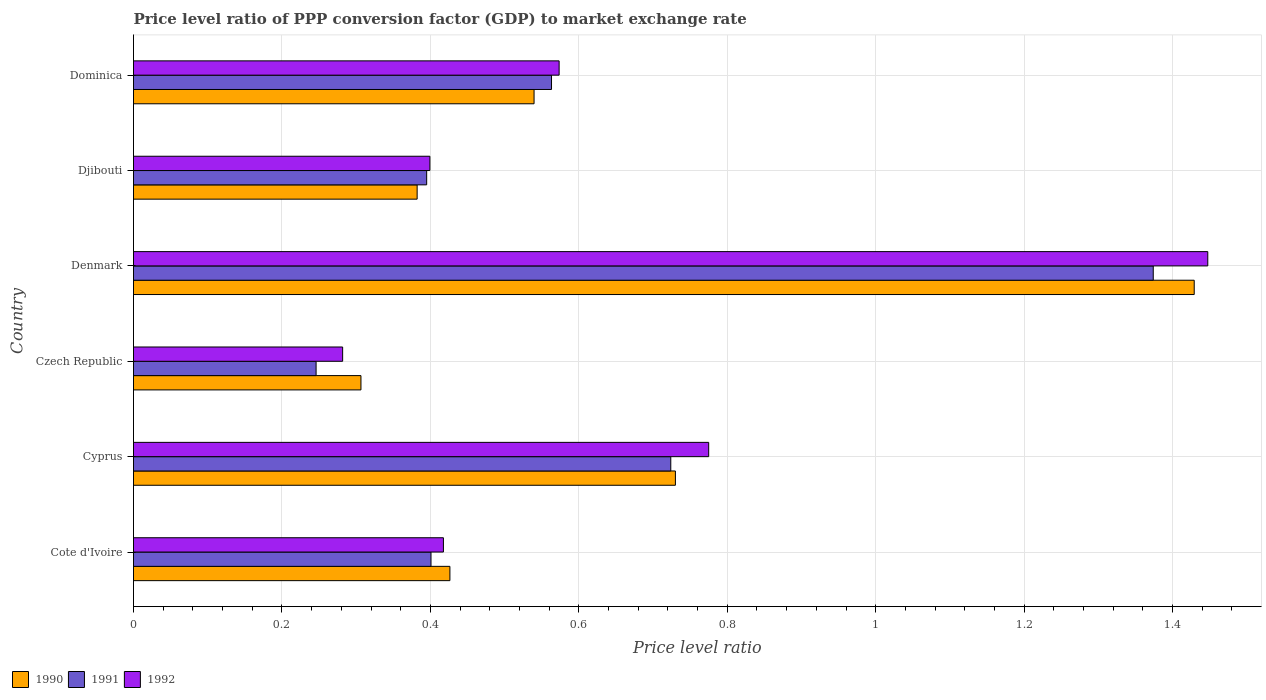How many groups of bars are there?
Provide a succinct answer. 6. Are the number of bars per tick equal to the number of legend labels?
Ensure brevity in your answer.  Yes. Are the number of bars on each tick of the Y-axis equal?
Your response must be concise. Yes. How many bars are there on the 3rd tick from the bottom?
Your response must be concise. 3. What is the label of the 2nd group of bars from the top?
Provide a succinct answer. Djibouti. What is the price level ratio in 1992 in Djibouti?
Keep it short and to the point. 0.4. Across all countries, what is the maximum price level ratio in 1990?
Your response must be concise. 1.43. Across all countries, what is the minimum price level ratio in 1990?
Offer a terse response. 0.31. In which country was the price level ratio in 1992 minimum?
Your answer should be very brief. Czech Republic. What is the total price level ratio in 1990 in the graph?
Your response must be concise. 3.81. What is the difference between the price level ratio in 1991 in Cote d'Ivoire and that in Cyprus?
Your response must be concise. -0.32. What is the difference between the price level ratio in 1990 in Dominica and the price level ratio in 1992 in Cote d'Ivoire?
Ensure brevity in your answer.  0.12. What is the average price level ratio in 1991 per country?
Offer a very short reply. 0.62. What is the difference between the price level ratio in 1990 and price level ratio in 1991 in Cyprus?
Offer a terse response. 0.01. What is the ratio of the price level ratio in 1991 in Cote d'Ivoire to that in Dominica?
Offer a very short reply. 0.71. Is the price level ratio in 1992 in Cyprus less than that in Czech Republic?
Give a very brief answer. No. Is the difference between the price level ratio in 1990 in Cote d'Ivoire and Djibouti greater than the difference between the price level ratio in 1991 in Cote d'Ivoire and Djibouti?
Make the answer very short. Yes. What is the difference between the highest and the second highest price level ratio in 1990?
Your response must be concise. 0.7. What is the difference between the highest and the lowest price level ratio in 1991?
Provide a short and direct response. 1.13. In how many countries, is the price level ratio in 1991 greater than the average price level ratio in 1991 taken over all countries?
Ensure brevity in your answer.  2. Is the sum of the price level ratio in 1990 in Denmark and Dominica greater than the maximum price level ratio in 1992 across all countries?
Give a very brief answer. Yes. What does the 3rd bar from the bottom in Denmark represents?
Ensure brevity in your answer.  1992. Are the values on the major ticks of X-axis written in scientific E-notation?
Your answer should be very brief. No. Does the graph contain any zero values?
Your answer should be very brief. No. Does the graph contain grids?
Keep it short and to the point. Yes. How many legend labels are there?
Keep it short and to the point. 3. How are the legend labels stacked?
Keep it short and to the point. Horizontal. What is the title of the graph?
Offer a terse response. Price level ratio of PPP conversion factor (GDP) to market exchange rate. Does "1968" appear as one of the legend labels in the graph?
Your response must be concise. No. What is the label or title of the X-axis?
Make the answer very short. Price level ratio. What is the Price level ratio of 1990 in Cote d'Ivoire?
Ensure brevity in your answer.  0.43. What is the Price level ratio of 1991 in Cote d'Ivoire?
Your answer should be very brief. 0.4. What is the Price level ratio of 1992 in Cote d'Ivoire?
Your answer should be compact. 0.42. What is the Price level ratio in 1990 in Cyprus?
Provide a short and direct response. 0.73. What is the Price level ratio in 1991 in Cyprus?
Your response must be concise. 0.72. What is the Price level ratio of 1992 in Cyprus?
Offer a terse response. 0.77. What is the Price level ratio of 1990 in Czech Republic?
Your answer should be compact. 0.31. What is the Price level ratio of 1991 in Czech Republic?
Keep it short and to the point. 0.25. What is the Price level ratio of 1992 in Czech Republic?
Make the answer very short. 0.28. What is the Price level ratio in 1990 in Denmark?
Keep it short and to the point. 1.43. What is the Price level ratio of 1991 in Denmark?
Your answer should be very brief. 1.37. What is the Price level ratio of 1992 in Denmark?
Your answer should be very brief. 1.45. What is the Price level ratio in 1990 in Djibouti?
Make the answer very short. 0.38. What is the Price level ratio of 1991 in Djibouti?
Ensure brevity in your answer.  0.4. What is the Price level ratio of 1992 in Djibouti?
Make the answer very short. 0.4. What is the Price level ratio in 1990 in Dominica?
Offer a very short reply. 0.54. What is the Price level ratio of 1991 in Dominica?
Your answer should be very brief. 0.56. What is the Price level ratio in 1992 in Dominica?
Your response must be concise. 0.57. Across all countries, what is the maximum Price level ratio in 1990?
Provide a succinct answer. 1.43. Across all countries, what is the maximum Price level ratio of 1991?
Ensure brevity in your answer.  1.37. Across all countries, what is the maximum Price level ratio in 1992?
Keep it short and to the point. 1.45. Across all countries, what is the minimum Price level ratio of 1990?
Make the answer very short. 0.31. Across all countries, what is the minimum Price level ratio in 1991?
Your response must be concise. 0.25. Across all countries, what is the minimum Price level ratio in 1992?
Provide a short and direct response. 0.28. What is the total Price level ratio of 1990 in the graph?
Your answer should be compact. 3.81. What is the total Price level ratio of 1991 in the graph?
Your answer should be compact. 3.7. What is the total Price level ratio of 1992 in the graph?
Your response must be concise. 3.89. What is the difference between the Price level ratio of 1990 in Cote d'Ivoire and that in Cyprus?
Your answer should be compact. -0.3. What is the difference between the Price level ratio of 1991 in Cote d'Ivoire and that in Cyprus?
Offer a very short reply. -0.32. What is the difference between the Price level ratio of 1992 in Cote d'Ivoire and that in Cyprus?
Your response must be concise. -0.36. What is the difference between the Price level ratio in 1990 in Cote d'Ivoire and that in Czech Republic?
Give a very brief answer. 0.12. What is the difference between the Price level ratio of 1991 in Cote d'Ivoire and that in Czech Republic?
Provide a short and direct response. 0.15. What is the difference between the Price level ratio of 1992 in Cote d'Ivoire and that in Czech Republic?
Offer a terse response. 0.14. What is the difference between the Price level ratio of 1990 in Cote d'Ivoire and that in Denmark?
Give a very brief answer. -1. What is the difference between the Price level ratio in 1991 in Cote d'Ivoire and that in Denmark?
Offer a terse response. -0.97. What is the difference between the Price level ratio of 1992 in Cote d'Ivoire and that in Denmark?
Your answer should be compact. -1.03. What is the difference between the Price level ratio in 1990 in Cote d'Ivoire and that in Djibouti?
Provide a succinct answer. 0.04. What is the difference between the Price level ratio of 1991 in Cote d'Ivoire and that in Djibouti?
Keep it short and to the point. 0.01. What is the difference between the Price level ratio in 1992 in Cote d'Ivoire and that in Djibouti?
Offer a terse response. 0.02. What is the difference between the Price level ratio in 1990 in Cote d'Ivoire and that in Dominica?
Ensure brevity in your answer.  -0.11. What is the difference between the Price level ratio of 1991 in Cote d'Ivoire and that in Dominica?
Provide a succinct answer. -0.16. What is the difference between the Price level ratio of 1992 in Cote d'Ivoire and that in Dominica?
Offer a terse response. -0.16. What is the difference between the Price level ratio in 1990 in Cyprus and that in Czech Republic?
Provide a short and direct response. 0.42. What is the difference between the Price level ratio of 1991 in Cyprus and that in Czech Republic?
Your answer should be compact. 0.48. What is the difference between the Price level ratio of 1992 in Cyprus and that in Czech Republic?
Provide a succinct answer. 0.49. What is the difference between the Price level ratio of 1990 in Cyprus and that in Denmark?
Your answer should be compact. -0.7. What is the difference between the Price level ratio in 1991 in Cyprus and that in Denmark?
Your answer should be very brief. -0.65. What is the difference between the Price level ratio of 1992 in Cyprus and that in Denmark?
Keep it short and to the point. -0.67. What is the difference between the Price level ratio of 1990 in Cyprus and that in Djibouti?
Your answer should be compact. 0.35. What is the difference between the Price level ratio in 1991 in Cyprus and that in Djibouti?
Offer a terse response. 0.33. What is the difference between the Price level ratio of 1992 in Cyprus and that in Djibouti?
Your answer should be compact. 0.38. What is the difference between the Price level ratio of 1990 in Cyprus and that in Dominica?
Your answer should be very brief. 0.19. What is the difference between the Price level ratio in 1991 in Cyprus and that in Dominica?
Give a very brief answer. 0.16. What is the difference between the Price level ratio in 1992 in Cyprus and that in Dominica?
Your answer should be compact. 0.2. What is the difference between the Price level ratio of 1990 in Czech Republic and that in Denmark?
Ensure brevity in your answer.  -1.12. What is the difference between the Price level ratio in 1991 in Czech Republic and that in Denmark?
Provide a short and direct response. -1.13. What is the difference between the Price level ratio in 1992 in Czech Republic and that in Denmark?
Offer a very short reply. -1.17. What is the difference between the Price level ratio in 1990 in Czech Republic and that in Djibouti?
Offer a terse response. -0.08. What is the difference between the Price level ratio of 1991 in Czech Republic and that in Djibouti?
Ensure brevity in your answer.  -0.15. What is the difference between the Price level ratio of 1992 in Czech Republic and that in Djibouti?
Make the answer very short. -0.12. What is the difference between the Price level ratio in 1990 in Czech Republic and that in Dominica?
Your response must be concise. -0.23. What is the difference between the Price level ratio in 1991 in Czech Republic and that in Dominica?
Give a very brief answer. -0.32. What is the difference between the Price level ratio in 1992 in Czech Republic and that in Dominica?
Give a very brief answer. -0.29. What is the difference between the Price level ratio of 1990 in Denmark and that in Djibouti?
Give a very brief answer. 1.05. What is the difference between the Price level ratio in 1992 in Denmark and that in Djibouti?
Make the answer very short. 1.05. What is the difference between the Price level ratio of 1990 in Denmark and that in Dominica?
Offer a very short reply. 0.89. What is the difference between the Price level ratio of 1991 in Denmark and that in Dominica?
Provide a short and direct response. 0.81. What is the difference between the Price level ratio of 1992 in Denmark and that in Dominica?
Provide a succinct answer. 0.87. What is the difference between the Price level ratio in 1990 in Djibouti and that in Dominica?
Offer a terse response. -0.16. What is the difference between the Price level ratio in 1991 in Djibouti and that in Dominica?
Your answer should be very brief. -0.17. What is the difference between the Price level ratio in 1992 in Djibouti and that in Dominica?
Provide a succinct answer. -0.17. What is the difference between the Price level ratio in 1990 in Cote d'Ivoire and the Price level ratio in 1991 in Cyprus?
Offer a very short reply. -0.3. What is the difference between the Price level ratio in 1990 in Cote d'Ivoire and the Price level ratio in 1992 in Cyprus?
Give a very brief answer. -0.35. What is the difference between the Price level ratio in 1991 in Cote d'Ivoire and the Price level ratio in 1992 in Cyprus?
Keep it short and to the point. -0.37. What is the difference between the Price level ratio of 1990 in Cote d'Ivoire and the Price level ratio of 1991 in Czech Republic?
Offer a very short reply. 0.18. What is the difference between the Price level ratio of 1990 in Cote d'Ivoire and the Price level ratio of 1992 in Czech Republic?
Give a very brief answer. 0.14. What is the difference between the Price level ratio of 1991 in Cote d'Ivoire and the Price level ratio of 1992 in Czech Republic?
Offer a terse response. 0.12. What is the difference between the Price level ratio of 1990 in Cote d'Ivoire and the Price level ratio of 1991 in Denmark?
Offer a very short reply. -0.95. What is the difference between the Price level ratio in 1990 in Cote d'Ivoire and the Price level ratio in 1992 in Denmark?
Offer a terse response. -1.02. What is the difference between the Price level ratio in 1991 in Cote d'Ivoire and the Price level ratio in 1992 in Denmark?
Make the answer very short. -1.05. What is the difference between the Price level ratio of 1990 in Cote d'Ivoire and the Price level ratio of 1991 in Djibouti?
Offer a very short reply. 0.03. What is the difference between the Price level ratio of 1990 in Cote d'Ivoire and the Price level ratio of 1992 in Djibouti?
Offer a very short reply. 0.03. What is the difference between the Price level ratio in 1991 in Cote d'Ivoire and the Price level ratio in 1992 in Djibouti?
Provide a succinct answer. 0. What is the difference between the Price level ratio in 1990 in Cote d'Ivoire and the Price level ratio in 1991 in Dominica?
Provide a short and direct response. -0.14. What is the difference between the Price level ratio in 1990 in Cote d'Ivoire and the Price level ratio in 1992 in Dominica?
Offer a terse response. -0.15. What is the difference between the Price level ratio in 1991 in Cote d'Ivoire and the Price level ratio in 1992 in Dominica?
Offer a terse response. -0.17. What is the difference between the Price level ratio of 1990 in Cyprus and the Price level ratio of 1991 in Czech Republic?
Keep it short and to the point. 0.48. What is the difference between the Price level ratio of 1990 in Cyprus and the Price level ratio of 1992 in Czech Republic?
Give a very brief answer. 0.45. What is the difference between the Price level ratio of 1991 in Cyprus and the Price level ratio of 1992 in Czech Republic?
Give a very brief answer. 0.44. What is the difference between the Price level ratio in 1990 in Cyprus and the Price level ratio in 1991 in Denmark?
Offer a very short reply. -0.64. What is the difference between the Price level ratio of 1990 in Cyprus and the Price level ratio of 1992 in Denmark?
Provide a succinct answer. -0.72. What is the difference between the Price level ratio of 1991 in Cyprus and the Price level ratio of 1992 in Denmark?
Give a very brief answer. -0.72. What is the difference between the Price level ratio of 1990 in Cyprus and the Price level ratio of 1991 in Djibouti?
Provide a short and direct response. 0.34. What is the difference between the Price level ratio in 1990 in Cyprus and the Price level ratio in 1992 in Djibouti?
Give a very brief answer. 0.33. What is the difference between the Price level ratio in 1991 in Cyprus and the Price level ratio in 1992 in Djibouti?
Your response must be concise. 0.32. What is the difference between the Price level ratio in 1990 in Cyprus and the Price level ratio in 1991 in Dominica?
Your response must be concise. 0.17. What is the difference between the Price level ratio in 1990 in Cyprus and the Price level ratio in 1992 in Dominica?
Keep it short and to the point. 0.16. What is the difference between the Price level ratio in 1991 in Cyprus and the Price level ratio in 1992 in Dominica?
Offer a terse response. 0.15. What is the difference between the Price level ratio of 1990 in Czech Republic and the Price level ratio of 1991 in Denmark?
Provide a succinct answer. -1.07. What is the difference between the Price level ratio of 1990 in Czech Republic and the Price level ratio of 1992 in Denmark?
Your answer should be very brief. -1.14. What is the difference between the Price level ratio of 1991 in Czech Republic and the Price level ratio of 1992 in Denmark?
Make the answer very short. -1.2. What is the difference between the Price level ratio in 1990 in Czech Republic and the Price level ratio in 1991 in Djibouti?
Your answer should be compact. -0.09. What is the difference between the Price level ratio in 1990 in Czech Republic and the Price level ratio in 1992 in Djibouti?
Provide a short and direct response. -0.09. What is the difference between the Price level ratio of 1991 in Czech Republic and the Price level ratio of 1992 in Djibouti?
Give a very brief answer. -0.15. What is the difference between the Price level ratio in 1990 in Czech Republic and the Price level ratio in 1991 in Dominica?
Give a very brief answer. -0.26. What is the difference between the Price level ratio in 1990 in Czech Republic and the Price level ratio in 1992 in Dominica?
Your answer should be compact. -0.27. What is the difference between the Price level ratio of 1991 in Czech Republic and the Price level ratio of 1992 in Dominica?
Your response must be concise. -0.33. What is the difference between the Price level ratio in 1990 in Denmark and the Price level ratio in 1991 in Djibouti?
Provide a short and direct response. 1.03. What is the difference between the Price level ratio of 1990 in Denmark and the Price level ratio of 1992 in Djibouti?
Make the answer very short. 1.03. What is the difference between the Price level ratio in 1991 in Denmark and the Price level ratio in 1992 in Djibouti?
Offer a terse response. 0.97. What is the difference between the Price level ratio of 1990 in Denmark and the Price level ratio of 1991 in Dominica?
Your response must be concise. 0.87. What is the difference between the Price level ratio of 1990 in Denmark and the Price level ratio of 1992 in Dominica?
Give a very brief answer. 0.86. What is the difference between the Price level ratio in 1991 in Denmark and the Price level ratio in 1992 in Dominica?
Give a very brief answer. 0.8. What is the difference between the Price level ratio in 1990 in Djibouti and the Price level ratio in 1991 in Dominica?
Your answer should be very brief. -0.18. What is the difference between the Price level ratio of 1990 in Djibouti and the Price level ratio of 1992 in Dominica?
Make the answer very short. -0.19. What is the difference between the Price level ratio of 1991 in Djibouti and the Price level ratio of 1992 in Dominica?
Ensure brevity in your answer.  -0.18. What is the average Price level ratio of 1990 per country?
Make the answer very short. 0.64. What is the average Price level ratio of 1991 per country?
Provide a succinct answer. 0.62. What is the average Price level ratio of 1992 per country?
Your answer should be very brief. 0.65. What is the difference between the Price level ratio in 1990 and Price level ratio in 1991 in Cote d'Ivoire?
Ensure brevity in your answer.  0.03. What is the difference between the Price level ratio in 1990 and Price level ratio in 1992 in Cote d'Ivoire?
Your answer should be compact. 0.01. What is the difference between the Price level ratio in 1991 and Price level ratio in 1992 in Cote d'Ivoire?
Provide a succinct answer. -0.02. What is the difference between the Price level ratio of 1990 and Price level ratio of 1991 in Cyprus?
Keep it short and to the point. 0.01. What is the difference between the Price level ratio of 1990 and Price level ratio of 1992 in Cyprus?
Give a very brief answer. -0.04. What is the difference between the Price level ratio of 1991 and Price level ratio of 1992 in Cyprus?
Make the answer very short. -0.05. What is the difference between the Price level ratio of 1990 and Price level ratio of 1991 in Czech Republic?
Provide a succinct answer. 0.06. What is the difference between the Price level ratio in 1990 and Price level ratio in 1992 in Czech Republic?
Provide a succinct answer. 0.02. What is the difference between the Price level ratio in 1991 and Price level ratio in 1992 in Czech Republic?
Make the answer very short. -0.04. What is the difference between the Price level ratio of 1990 and Price level ratio of 1991 in Denmark?
Your response must be concise. 0.06. What is the difference between the Price level ratio in 1990 and Price level ratio in 1992 in Denmark?
Keep it short and to the point. -0.02. What is the difference between the Price level ratio in 1991 and Price level ratio in 1992 in Denmark?
Offer a terse response. -0.07. What is the difference between the Price level ratio of 1990 and Price level ratio of 1991 in Djibouti?
Make the answer very short. -0.01. What is the difference between the Price level ratio in 1990 and Price level ratio in 1992 in Djibouti?
Your response must be concise. -0.02. What is the difference between the Price level ratio in 1991 and Price level ratio in 1992 in Djibouti?
Provide a succinct answer. -0. What is the difference between the Price level ratio in 1990 and Price level ratio in 1991 in Dominica?
Ensure brevity in your answer.  -0.02. What is the difference between the Price level ratio of 1990 and Price level ratio of 1992 in Dominica?
Make the answer very short. -0.03. What is the difference between the Price level ratio in 1991 and Price level ratio in 1992 in Dominica?
Make the answer very short. -0.01. What is the ratio of the Price level ratio in 1990 in Cote d'Ivoire to that in Cyprus?
Provide a short and direct response. 0.58. What is the ratio of the Price level ratio in 1991 in Cote d'Ivoire to that in Cyprus?
Give a very brief answer. 0.55. What is the ratio of the Price level ratio of 1992 in Cote d'Ivoire to that in Cyprus?
Provide a short and direct response. 0.54. What is the ratio of the Price level ratio in 1990 in Cote d'Ivoire to that in Czech Republic?
Offer a very short reply. 1.39. What is the ratio of the Price level ratio of 1991 in Cote d'Ivoire to that in Czech Republic?
Offer a terse response. 1.63. What is the ratio of the Price level ratio of 1992 in Cote d'Ivoire to that in Czech Republic?
Make the answer very short. 1.48. What is the ratio of the Price level ratio of 1990 in Cote d'Ivoire to that in Denmark?
Ensure brevity in your answer.  0.3. What is the ratio of the Price level ratio in 1991 in Cote d'Ivoire to that in Denmark?
Your response must be concise. 0.29. What is the ratio of the Price level ratio of 1992 in Cote d'Ivoire to that in Denmark?
Your answer should be very brief. 0.29. What is the ratio of the Price level ratio of 1990 in Cote d'Ivoire to that in Djibouti?
Your answer should be compact. 1.12. What is the ratio of the Price level ratio in 1991 in Cote d'Ivoire to that in Djibouti?
Offer a terse response. 1.01. What is the ratio of the Price level ratio of 1992 in Cote d'Ivoire to that in Djibouti?
Ensure brevity in your answer.  1.05. What is the ratio of the Price level ratio in 1990 in Cote d'Ivoire to that in Dominica?
Keep it short and to the point. 0.79. What is the ratio of the Price level ratio in 1991 in Cote d'Ivoire to that in Dominica?
Your answer should be compact. 0.71. What is the ratio of the Price level ratio in 1992 in Cote d'Ivoire to that in Dominica?
Make the answer very short. 0.73. What is the ratio of the Price level ratio in 1990 in Cyprus to that in Czech Republic?
Ensure brevity in your answer.  2.38. What is the ratio of the Price level ratio of 1991 in Cyprus to that in Czech Republic?
Your response must be concise. 2.94. What is the ratio of the Price level ratio in 1992 in Cyprus to that in Czech Republic?
Ensure brevity in your answer.  2.75. What is the ratio of the Price level ratio of 1990 in Cyprus to that in Denmark?
Keep it short and to the point. 0.51. What is the ratio of the Price level ratio of 1991 in Cyprus to that in Denmark?
Keep it short and to the point. 0.53. What is the ratio of the Price level ratio in 1992 in Cyprus to that in Denmark?
Ensure brevity in your answer.  0.54. What is the ratio of the Price level ratio of 1990 in Cyprus to that in Djibouti?
Offer a terse response. 1.91. What is the ratio of the Price level ratio of 1991 in Cyprus to that in Djibouti?
Provide a short and direct response. 1.83. What is the ratio of the Price level ratio of 1992 in Cyprus to that in Djibouti?
Your response must be concise. 1.94. What is the ratio of the Price level ratio of 1990 in Cyprus to that in Dominica?
Ensure brevity in your answer.  1.35. What is the ratio of the Price level ratio in 1991 in Cyprus to that in Dominica?
Ensure brevity in your answer.  1.29. What is the ratio of the Price level ratio of 1992 in Cyprus to that in Dominica?
Ensure brevity in your answer.  1.35. What is the ratio of the Price level ratio in 1990 in Czech Republic to that in Denmark?
Provide a succinct answer. 0.21. What is the ratio of the Price level ratio of 1991 in Czech Republic to that in Denmark?
Provide a succinct answer. 0.18. What is the ratio of the Price level ratio of 1992 in Czech Republic to that in Denmark?
Keep it short and to the point. 0.19. What is the ratio of the Price level ratio in 1990 in Czech Republic to that in Djibouti?
Make the answer very short. 0.8. What is the ratio of the Price level ratio in 1991 in Czech Republic to that in Djibouti?
Your answer should be compact. 0.62. What is the ratio of the Price level ratio of 1992 in Czech Republic to that in Djibouti?
Your response must be concise. 0.71. What is the ratio of the Price level ratio in 1990 in Czech Republic to that in Dominica?
Your answer should be very brief. 0.57. What is the ratio of the Price level ratio in 1991 in Czech Republic to that in Dominica?
Your answer should be compact. 0.44. What is the ratio of the Price level ratio in 1992 in Czech Republic to that in Dominica?
Make the answer very short. 0.49. What is the ratio of the Price level ratio in 1990 in Denmark to that in Djibouti?
Your answer should be very brief. 3.74. What is the ratio of the Price level ratio of 1991 in Denmark to that in Djibouti?
Offer a terse response. 3.48. What is the ratio of the Price level ratio in 1992 in Denmark to that in Djibouti?
Provide a short and direct response. 3.62. What is the ratio of the Price level ratio of 1990 in Denmark to that in Dominica?
Provide a short and direct response. 2.65. What is the ratio of the Price level ratio in 1991 in Denmark to that in Dominica?
Provide a short and direct response. 2.44. What is the ratio of the Price level ratio of 1992 in Denmark to that in Dominica?
Keep it short and to the point. 2.52. What is the ratio of the Price level ratio in 1990 in Djibouti to that in Dominica?
Provide a short and direct response. 0.71. What is the ratio of the Price level ratio of 1991 in Djibouti to that in Dominica?
Give a very brief answer. 0.7. What is the ratio of the Price level ratio in 1992 in Djibouti to that in Dominica?
Offer a very short reply. 0.7. What is the difference between the highest and the second highest Price level ratio in 1990?
Make the answer very short. 0.7. What is the difference between the highest and the second highest Price level ratio of 1991?
Your response must be concise. 0.65. What is the difference between the highest and the second highest Price level ratio of 1992?
Offer a terse response. 0.67. What is the difference between the highest and the lowest Price level ratio in 1990?
Give a very brief answer. 1.12. What is the difference between the highest and the lowest Price level ratio in 1991?
Ensure brevity in your answer.  1.13. What is the difference between the highest and the lowest Price level ratio in 1992?
Give a very brief answer. 1.17. 